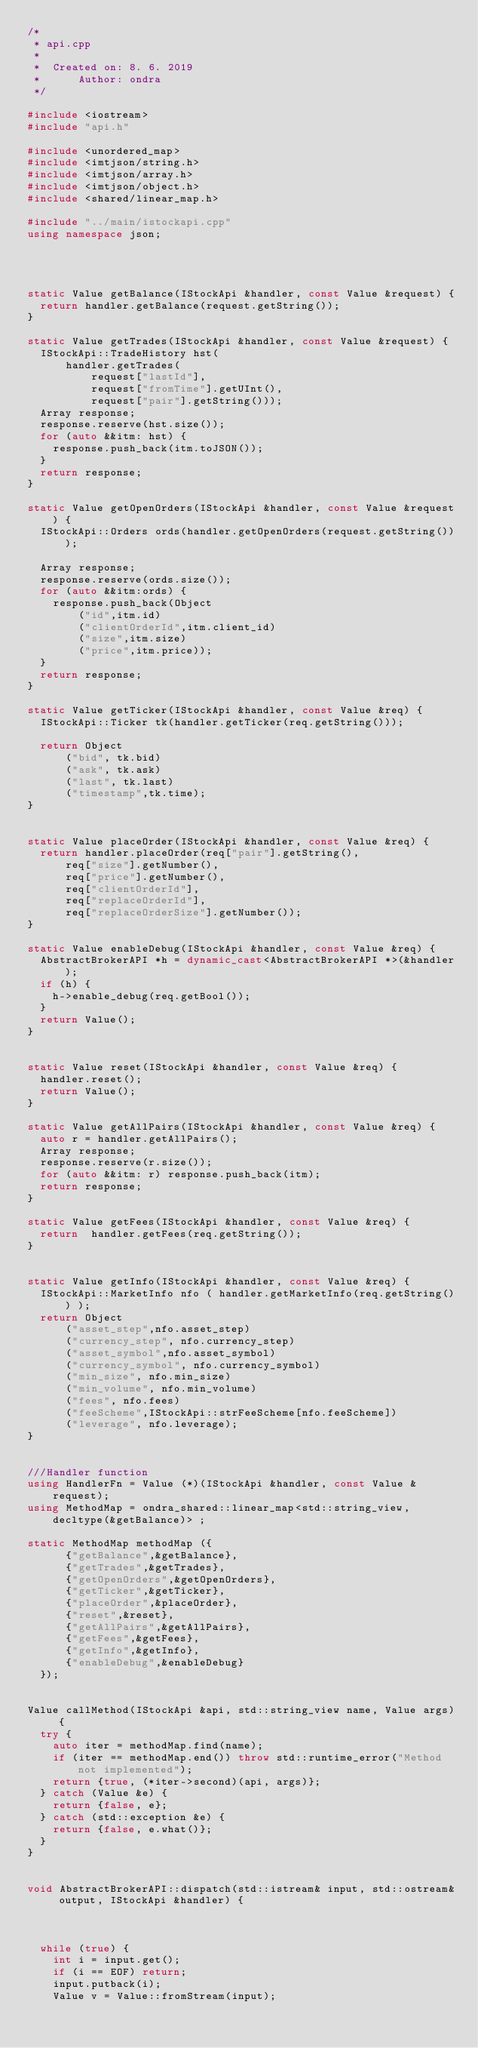<code> <loc_0><loc_0><loc_500><loc_500><_C++_>/*
 * api.cpp
 *
 *  Created on: 8. 6. 2019
 *      Author: ondra
 */

#include <iostream>
#include "api.h"

#include <unordered_map>
#include <imtjson/string.h>
#include <imtjson/array.h>
#include <imtjson/object.h>
#include <shared/linear_map.h>

#include "../main/istockapi.cpp"
using namespace json;




static Value getBalance(IStockApi &handler, const Value &request) {
	return handler.getBalance(request.getString());
}

static Value getTrades(IStockApi &handler, const Value &request) {
	IStockApi::TradeHistory hst(
			handler.getTrades(
					request["lastId"],
					request["fromTime"].getUInt(),
					request["pair"].getString()));
	Array response;
	response.reserve(hst.size());
	for (auto &&itm: hst) {
		response.push_back(itm.toJSON());
	}
	return response;
}

static Value getOpenOrders(IStockApi &handler, const Value &request) {
	IStockApi::Orders ords(handler.getOpenOrders(request.getString()));

	Array response;
	response.reserve(ords.size());
	for (auto &&itm:ords) {
		response.push_back(Object
				("id",itm.id)
				("clientOrderId",itm.client_id)
				("size",itm.size)
				("price",itm.price));
	}
	return response;
}

static Value getTicker(IStockApi &handler, const Value &req) {
	IStockApi::Ticker tk(handler.getTicker(req.getString()));

	return Object
			("bid", tk.bid)
			("ask", tk.ask)
			("last", tk.last)
			("timestamp",tk.time);
}


static Value placeOrder(IStockApi &handler, const Value &req) {
	return handler.placeOrder(req["pair"].getString(),
			req["size"].getNumber(),
			req["price"].getNumber(),
			req["clientOrderId"],
			req["replaceOrderId"],
			req["replaceOrderSize"].getNumber());
}

static Value enableDebug(IStockApi &handler, const Value &req) {
	AbstractBrokerAPI *h = dynamic_cast<AbstractBrokerAPI *>(&handler);
	if (h) {
		h->enable_debug(req.getBool());
	}
	return Value();
}


static Value reset(IStockApi &handler, const Value &req) {
	handler.reset();
	return Value();
}

static Value getAllPairs(IStockApi &handler, const Value &req) {
	auto r = handler.getAllPairs();
	Array response;
	response.reserve(r.size());
	for (auto &&itm: r) response.push_back(itm);
	return response;
}

static Value getFees(IStockApi &handler, const Value &req) {
	return  handler.getFees(req.getString());
}


static Value getInfo(IStockApi &handler, const Value &req) {
	IStockApi::MarketInfo nfo ( handler.getMarketInfo(req.getString()) );
	return Object
			("asset_step",nfo.asset_step)
			("currency_step", nfo.currency_step)
			("asset_symbol",nfo.asset_symbol)
			("currency_symbol", nfo.currency_symbol)
			("min_size", nfo.min_size)
			("min_volume", nfo.min_volume)
			("fees", nfo.fees)
			("feeScheme",IStockApi::strFeeScheme[nfo.feeScheme])
			("leverage", nfo.leverage);
}


///Handler function
using HandlerFn = Value (*)(IStockApi &handler, const Value &request);
using MethodMap = ondra_shared::linear_map<std::string_view, decltype(&getBalance)> ;

static MethodMap methodMap ({
			{"getBalance",&getBalance},
			{"getTrades",&getTrades},
			{"getOpenOrders",&getOpenOrders},
			{"getTicker",&getTicker},
			{"placeOrder",&placeOrder},
			{"reset",&reset},
			{"getAllPairs",&getAllPairs},
			{"getFees",&getFees},
			{"getInfo",&getInfo},
			{"enableDebug",&enableDebug}
	});


Value callMethod(IStockApi &api, std::string_view name, Value args) {
	try {
		auto iter = methodMap.find(name);
		if (iter == methodMap.end()) throw std::runtime_error("Method not implemented");
		return {true, (*iter->second)(api, args)};
	} catch (Value &e) {
		return {false, e};
	} catch (std::exception &e) {
		return {false, e.what()};
	}
}


void AbstractBrokerAPI::dispatch(std::istream& input, std::ostream& output, IStockApi &handler) {



	while (true) {
		int i = input.get();
		if (i == EOF) return;
		input.putback(i);
		Value v = Value::fromStream(input);</code> 